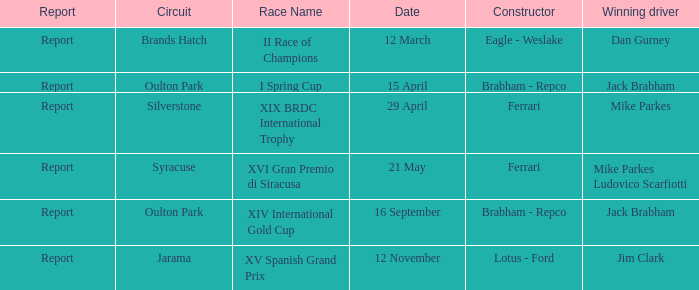What date was the xiv international gold cup? 16 September. 